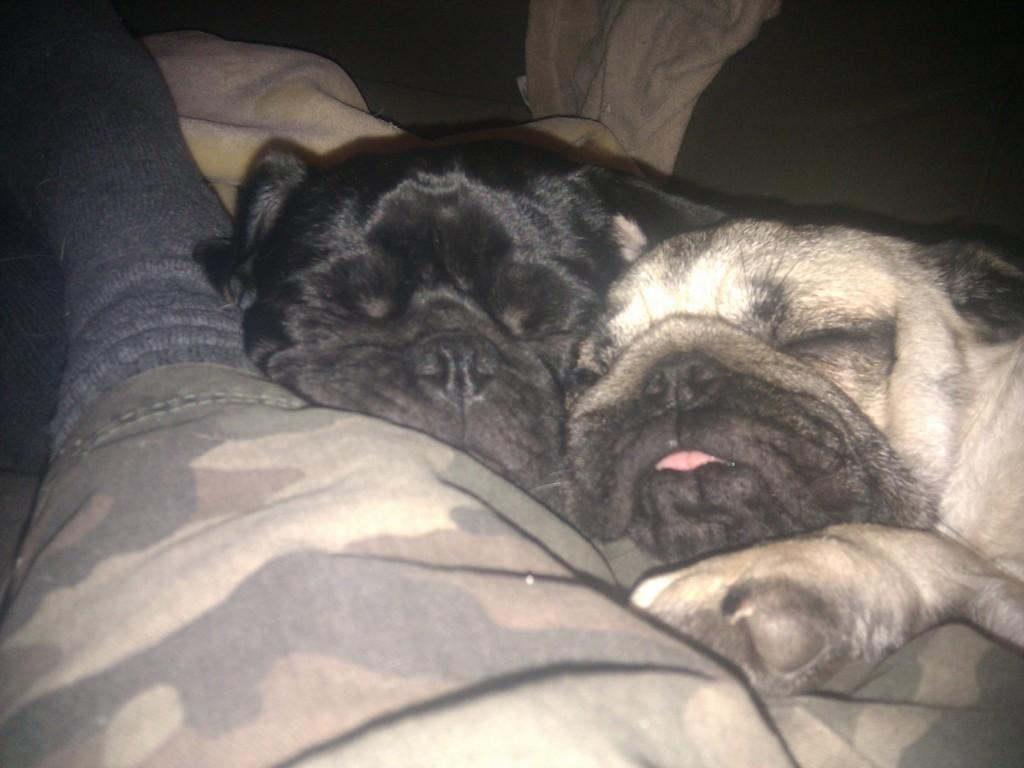What type of animal is present in the image? There is a dog in the image. What is the dog doing in the image? The dog is taking a nap. Where is the dog's grandmother sitting in the image? There is no mention of a grandmother or any seating in the image; it only features a dog taking a nap. What type of crate is the dog sitting in in the image? There is no crate present in the image; it only features a dog taking a nap. 